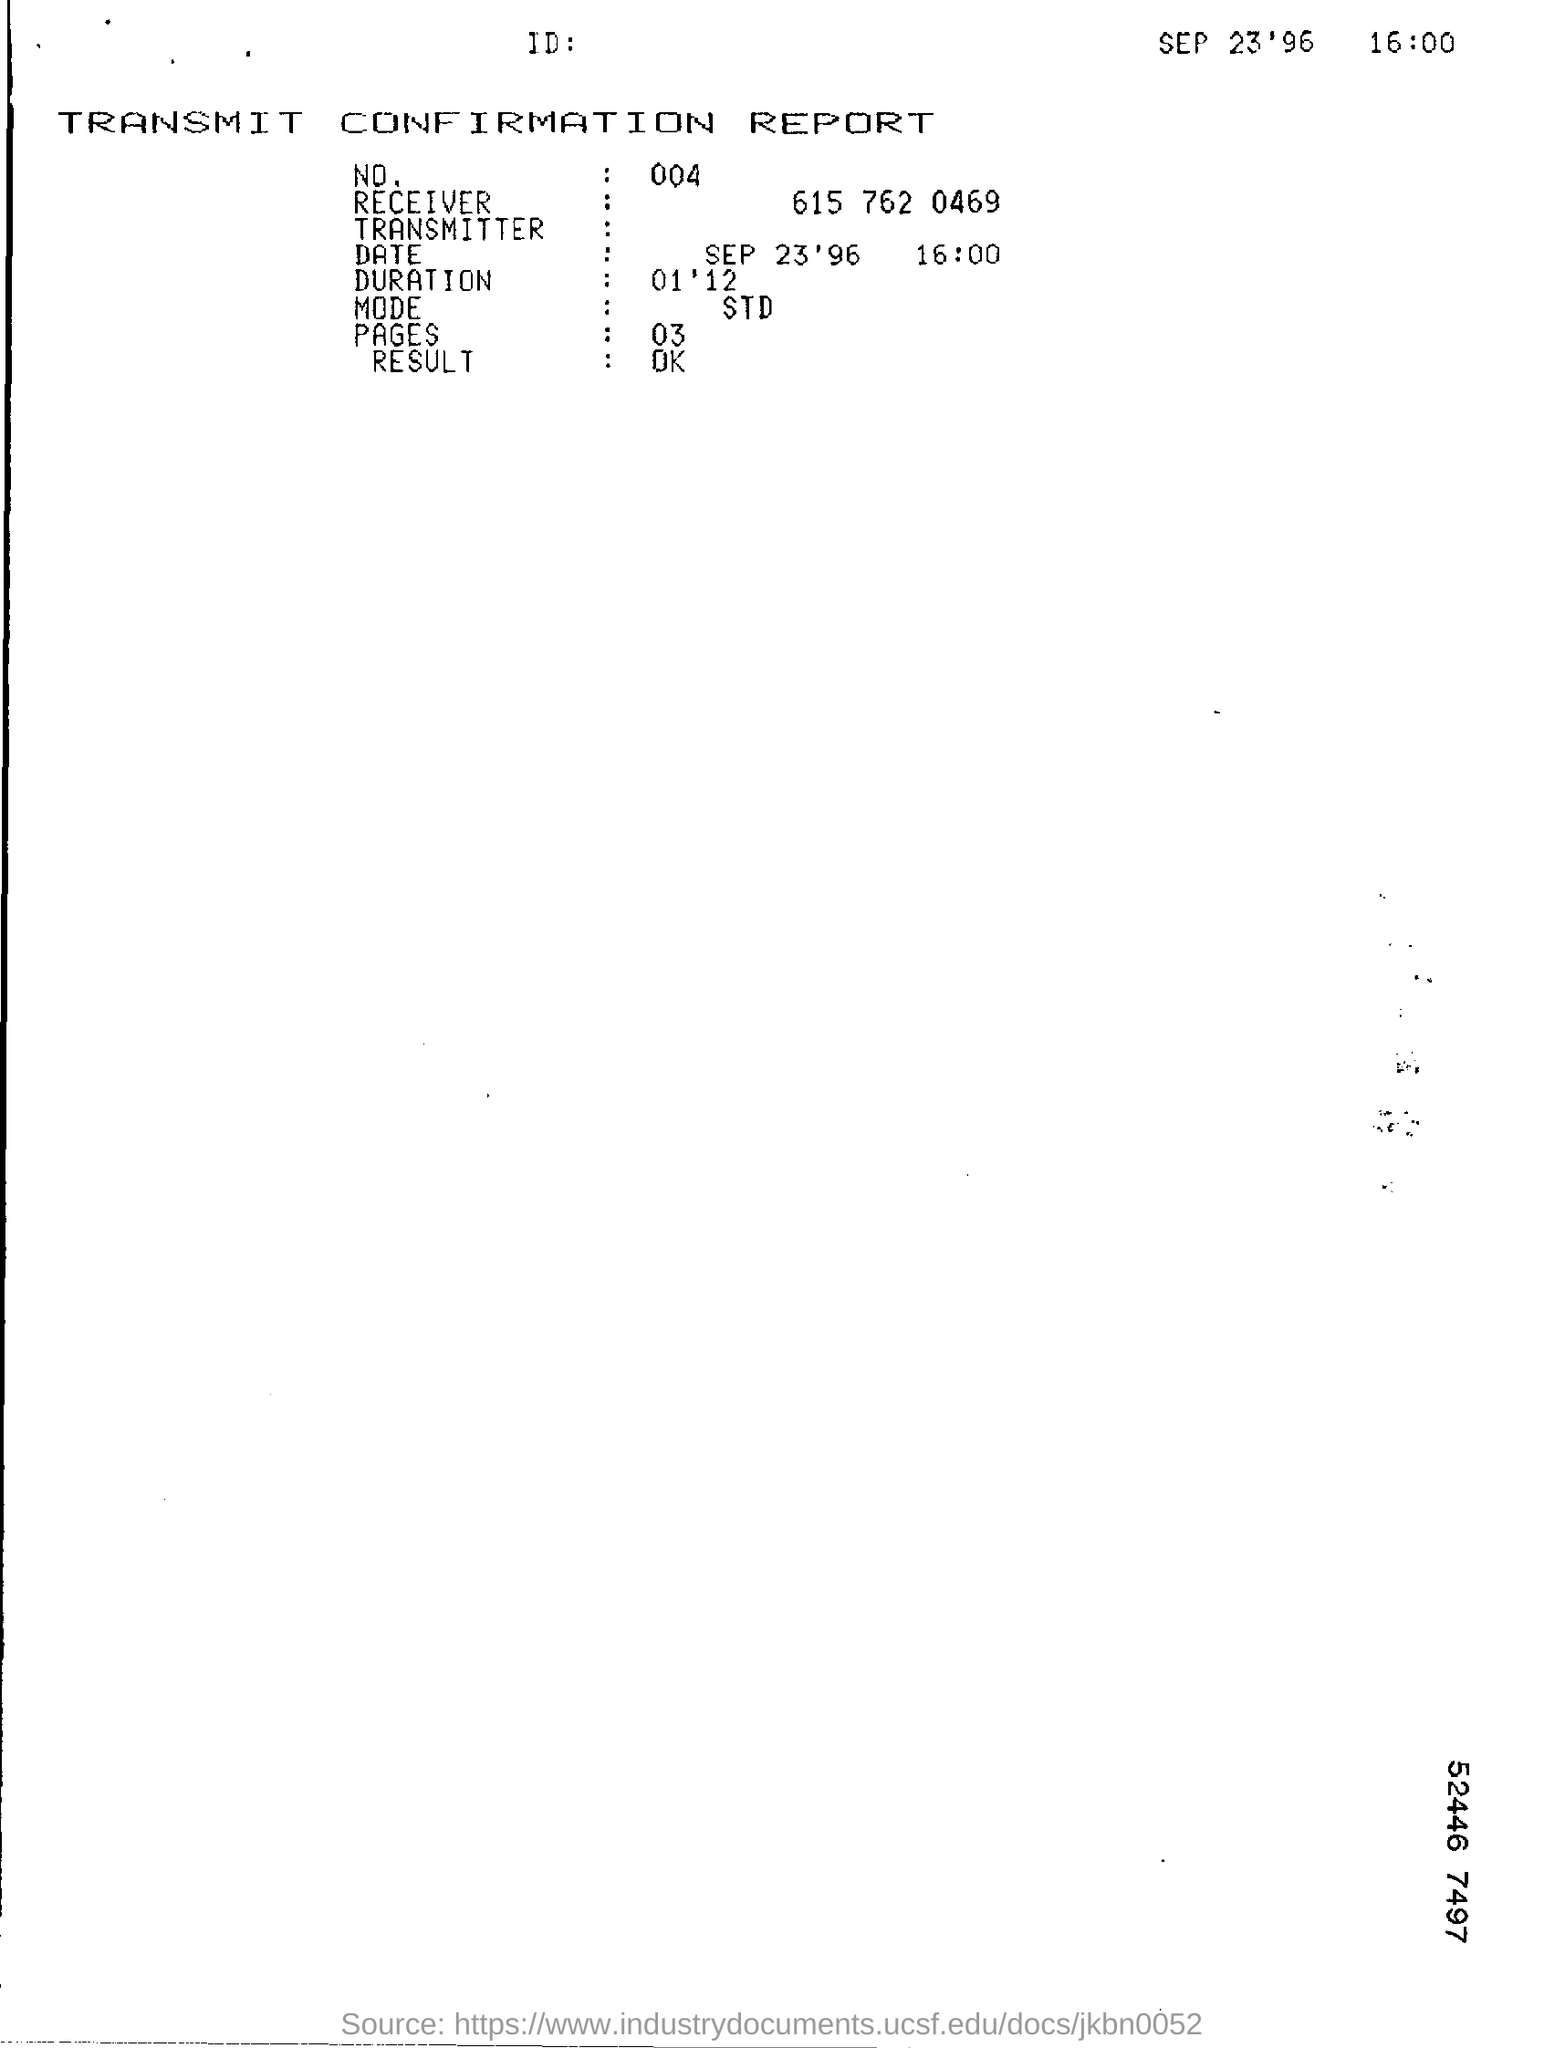How might this document have been crucial for business operations at the time? Fax transmission confirmation reports were vital for businesses as they served as a proof of dispatch and receipt. They were often used for legal and financial documents where verification of transmission was necessary to proceed with various operations. In the event of a dispute or a need for confirmation, these reports could be referenced as evidence that the documents were successfully transmitted.  What does the duration of the transmission tell us? The duration of the transmission, in this case, one minute and twelve seconds, indicates the speed at which the fax machine was able to send three pages. This could reflect on the efficiency of the equipment and the line quality at the time. Quicker transmission times were often preferred in business settings to save time and ensure quick communication. 